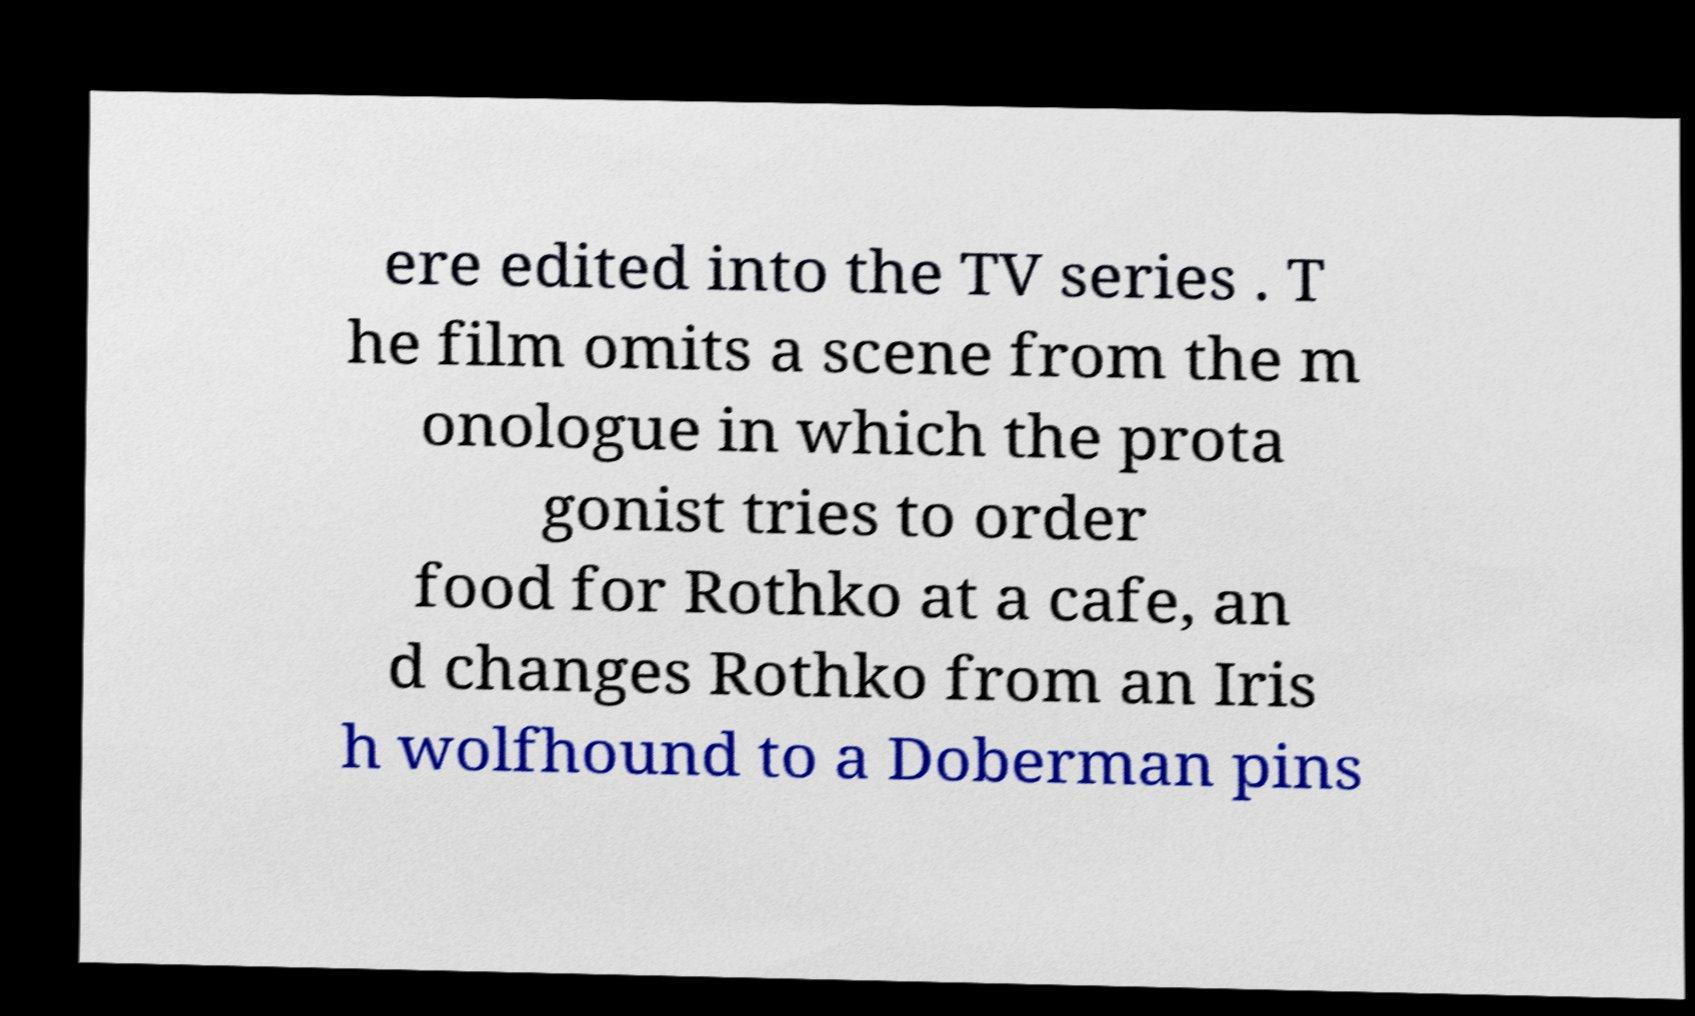I need the written content from this picture converted into text. Can you do that? ere edited into the TV series . T he film omits a scene from the m onologue in which the prota gonist tries to order food for Rothko at a cafe, an d changes Rothko from an Iris h wolfhound to a Doberman pins 